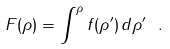<formula> <loc_0><loc_0><loc_500><loc_500>F ( \rho ) = \int ^ { \rho } f ( \rho ^ { \prime } ) \, d \rho ^ { \prime } \ .</formula> 